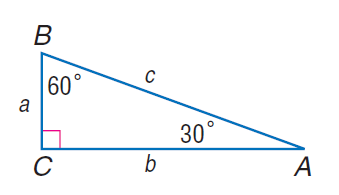Answer the mathemtical geometry problem and directly provide the correct option letter.
Question: If c = 8, find b.
Choices: A: 4 B: 4 \sqrt { 3 } C: 8 D: 8 \sqrt { 3 } B 